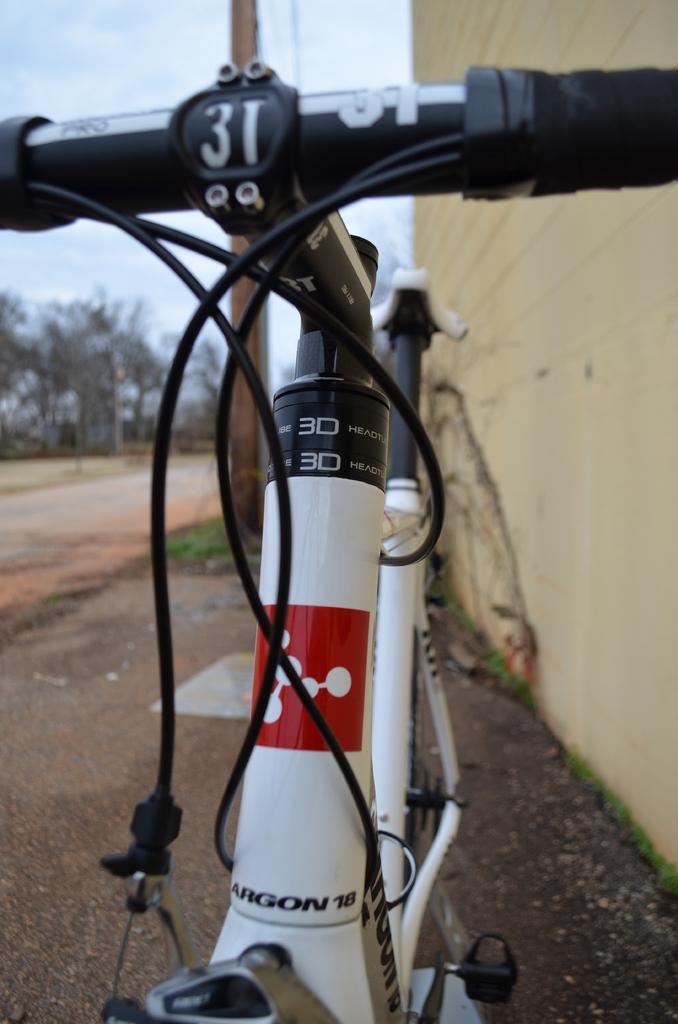In one or two sentences, can you explain what this image depicts? In the picture we can see a part of the bicycle, which is white in color with black color handle parked near the wall which is cream in color and to the path we can see some part of grass and in the background we can see some trees and behind it we can see the sky with clouds. 